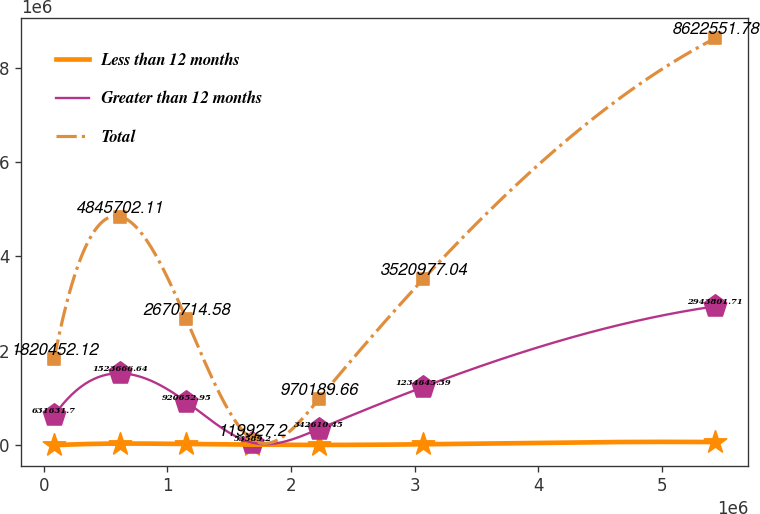<chart> <loc_0><loc_0><loc_500><loc_500><line_chart><ecel><fcel>Less than 12 months<fcel>Greater than 12 months<fcel>Total<nl><fcel>83068.1<fcel>851.53<fcel>631632<fcel>1.82045e+06<nl><fcel>618094<fcel>36029.5<fcel>1.52367e+06<fcel>4.8457e+06<nl><fcel>1.15312e+06<fcel>27535.9<fcel>920653<fcel>2.67071e+06<nl><fcel>1.68815e+06<fcel>14193.7<fcel>53589.2<fcel>119927<nl><fcel>2.22317e+06<fcel>7522.63<fcel>342610<fcel>970190<nl><fcel>3.07023e+06<fcel>20864.8<fcel>1.23465e+06<fcel>3.52098e+06<nl><fcel>5.43333e+06<fcel>67562.5<fcel>2.9438e+06<fcel>8.62255e+06<nl></chart> 